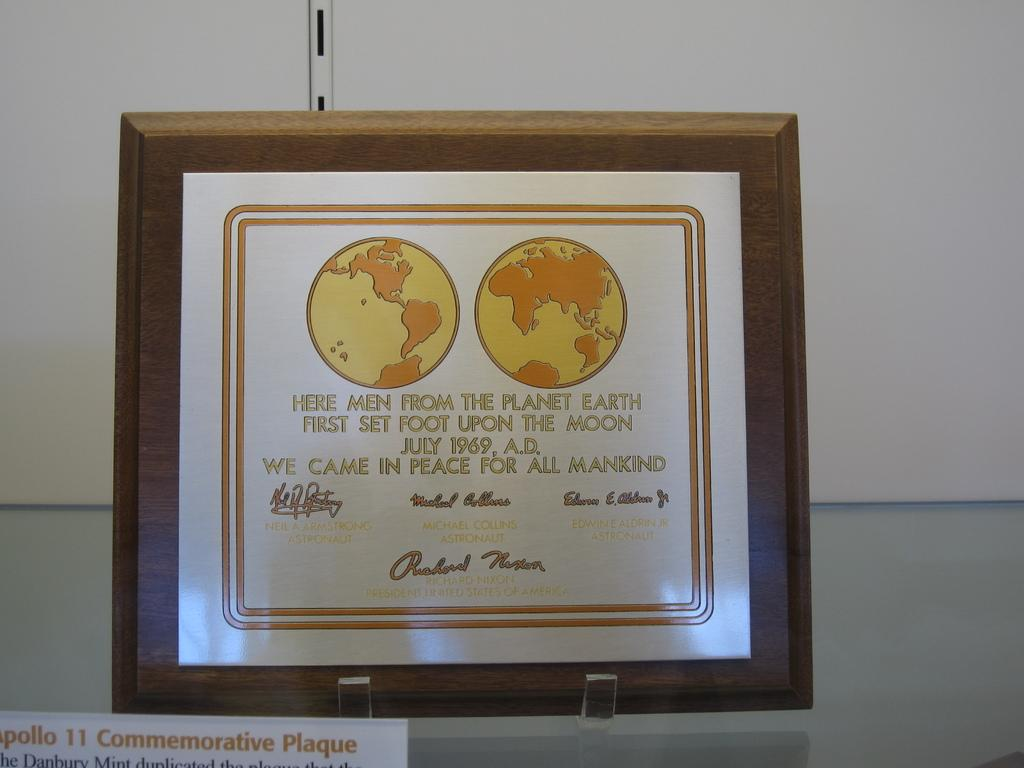<image>
Give a short and clear explanation of the subsequent image. a photo of the planet earth that is framed 